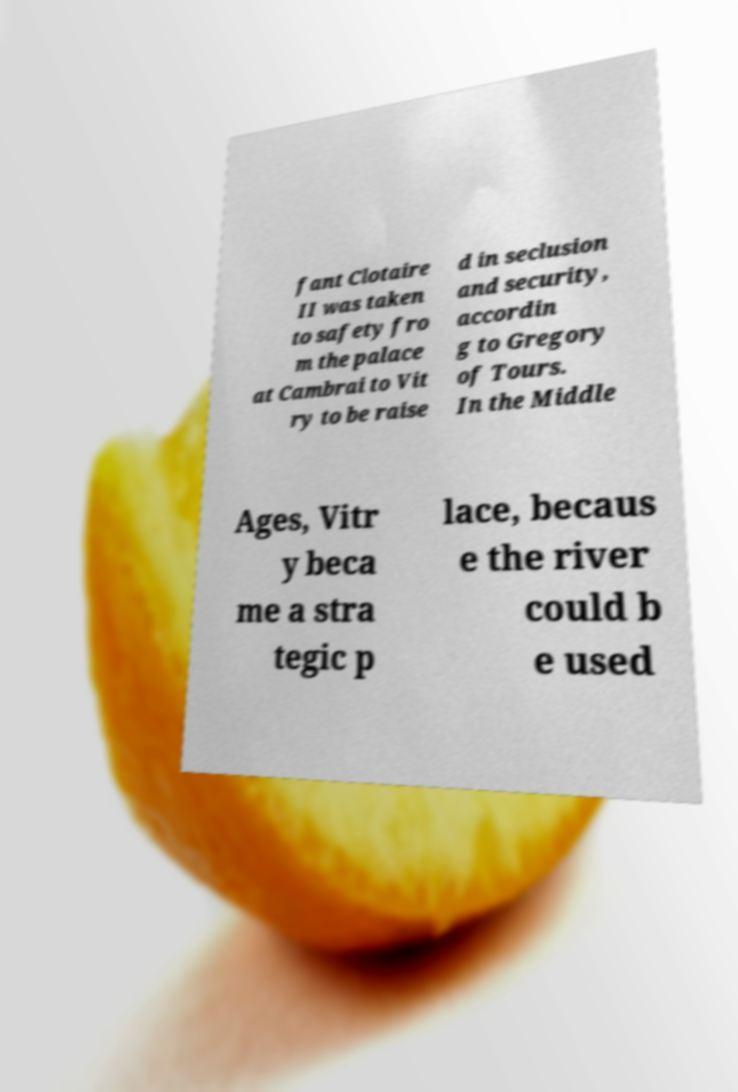For documentation purposes, I need the text within this image transcribed. Could you provide that? fant Clotaire II was taken to safety fro m the palace at Cambrai to Vit ry to be raise d in seclusion and security, accordin g to Gregory of Tours. In the Middle Ages, Vitr y beca me a stra tegic p lace, becaus e the river could b e used 